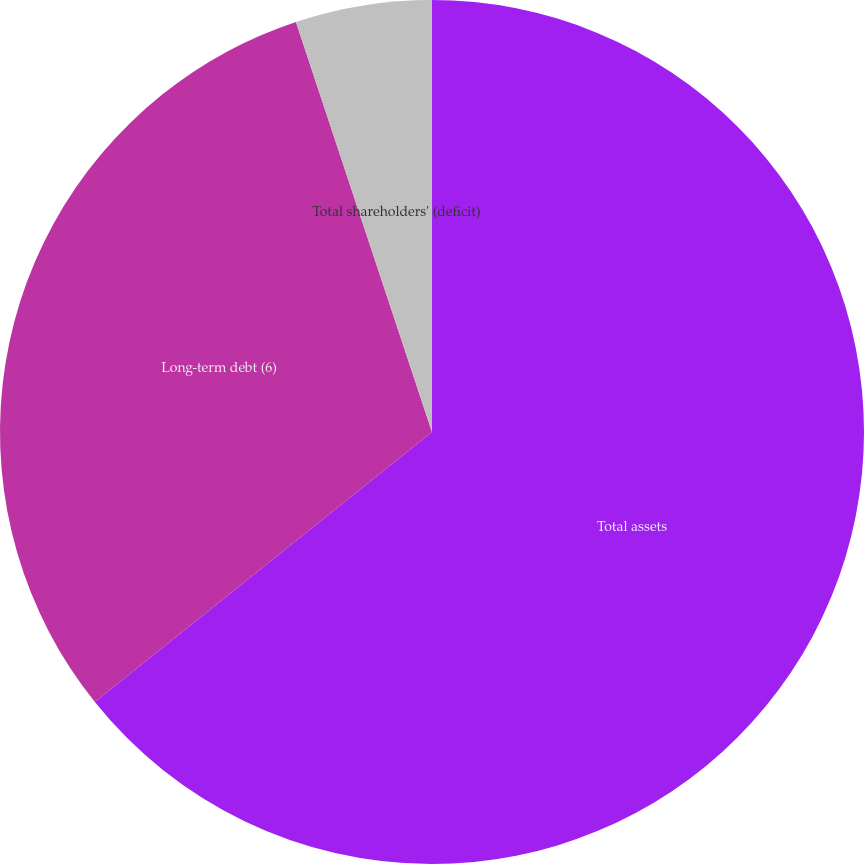Convert chart to OTSL. <chart><loc_0><loc_0><loc_500><loc_500><pie_chart><fcel>Total assets<fcel>Long-term debt (6)<fcel>Total shareholders' (deficit)<nl><fcel>64.25%<fcel>30.65%<fcel>5.1%<nl></chart> 